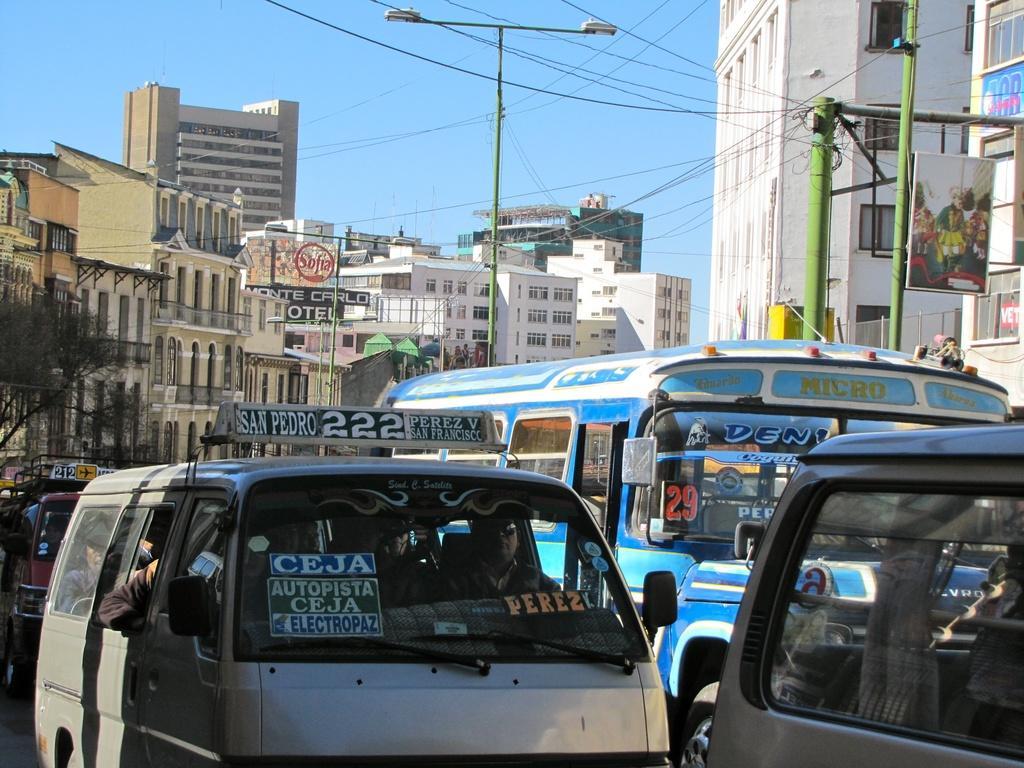Describe this image in one or two sentences. In this image I can see number of vehicles in the front and on these vehicles I can see something is written. On the left side of the image I can see few people are sitting in the vehicle. In the background I can see few trees, number of poles, few street lights, number of wires, number of buildings, number of boards, the sky and on these boards I can see something is written. 